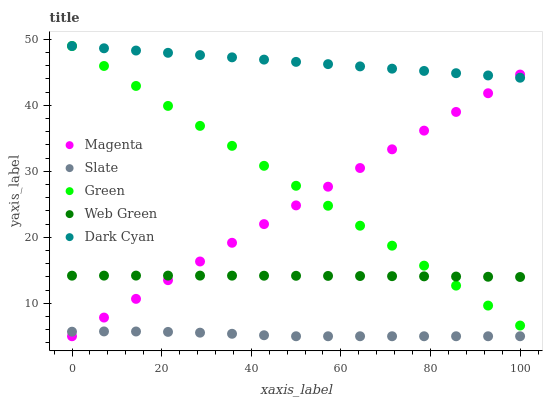Does Slate have the minimum area under the curve?
Answer yes or no. Yes. Does Dark Cyan have the maximum area under the curve?
Answer yes or no. Yes. Does Magenta have the minimum area under the curve?
Answer yes or no. No. Does Magenta have the maximum area under the curve?
Answer yes or no. No. Is Magenta the smoothest?
Answer yes or no. Yes. Is Slate the roughest?
Answer yes or no. Yes. Is Green the smoothest?
Answer yes or no. No. Is Green the roughest?
Answer yes or no. No. Does Magenta have the lowest value?
Answer yes or no. Yes. Does Green have the lowest value?
Answer yes or no. No. Does Green have the highest value?
Answer yes or no. Yes. Does Magenta have the highest value?
Answer yes or no. No. Is Web Green less than Dark Cyan?
Answer yes or no. Yes. Is Dark Cyan greater than Web Green?
Answer yes or no. Yes. Does Green intersect Web Green?
Answer yes or no. Yes. Is Green less than Web Green?
Answer yes or no. No. Is Green greater than Web Green?
Answer yes or no. No. Does Web Green intersect Dark Cyan?
Answer yes or no. No. 